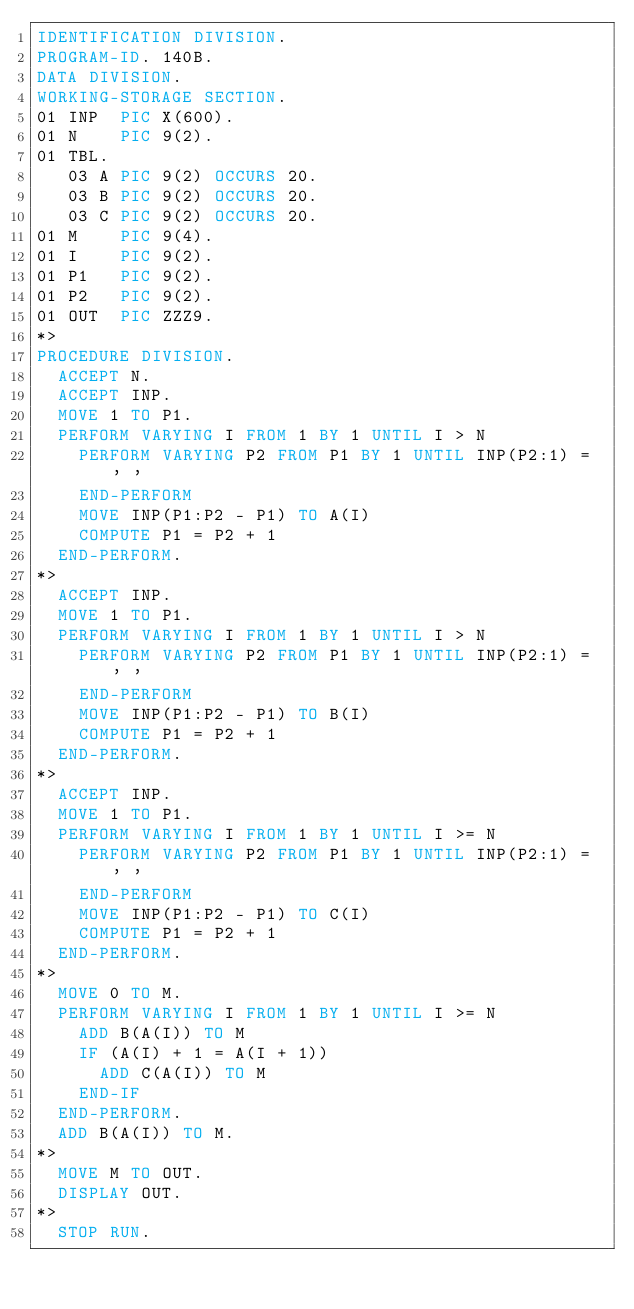<code> <loc_0><loc_0><loc_500><loc_500><_COBOL_>IDENTIFICATION DIVISION.
PROGRAM-ID. 140B.
DATA DIVISION.
WORKING-STORAGE SECTION.
01 INP  PIC X(600).
01 N    PIC 9(2).
01 TBL.
   03 A PIC 9(2) OCCURS 20.
   03 B PIC 9(2) OCCURS 20.
   03 C PIC 9(2) OCCURS 20.
01 M    PIC 9(4).
01 I    PIC 9(2).
01 P1   PIC 9(2).
01 P2   PIC 9(2).
01 OUT  PIC ZZZ9.
*>  
PROCEDURE DIVISION.
  ACCEPT N.
  ACCEPT INP.
  MOVE 1 TO P1.
  PERFORM VARYING I FROM 1 BY 1 UNTIL I > N
    PERFORM VARYING P2 FROM P1 BY 1 UNTIL INP(P2:1) = ' '
    END-PERFORM
    MOVE INP(P1:P2 - P1) TO A(I)
    COMPUTE P1 = P2 + 1
  END-PERFORM.
*>
  ACCEPT INP.
  MOVE 1 TO P1.
  PERFORM VARYING I FROM 1 BY 1 UNTIL I > N
    PERFORM VARYING P2 FROM P1 BY 1 UNTIL INP(P2:1) = ' '
    END-PERFORM
    MOVE INP(P1:P2 - P1) TO B(I)
    COMPUTE P1 = P2 + 1
  END-PERFORM.
*>
  ACCEPT INP.
  MOVE 1 TO P1.
  PERFORM VARYING I FROM 1 BY 1 UNTIL I >= N
    PERFORM VARYING P2 FROM P1 BY 1 UNTIL INP(P2:1) = ' '
    END-PERFORM
    MOVE INP(P1:P2 - P1) TO C(I)
    COMPUTE P1 = P2 + 1
  END-PERFORM.
*>
  MOVE 0 TO M.
  PERFORM VARYING I FROM 1 BY 1 UNTIL I >= N
    ADD B(A(I)) TO M
    IF (A(I) + 1 = A(I + 1))
      ADD C(A(I)) TO M
    END-IF
  END-PERFORM.
  ADD B(A(I)) TO M.
*>
  MOVE M TO OUT.
  DISPLAY OUT.
*>
  STOP RUN.
</code> 